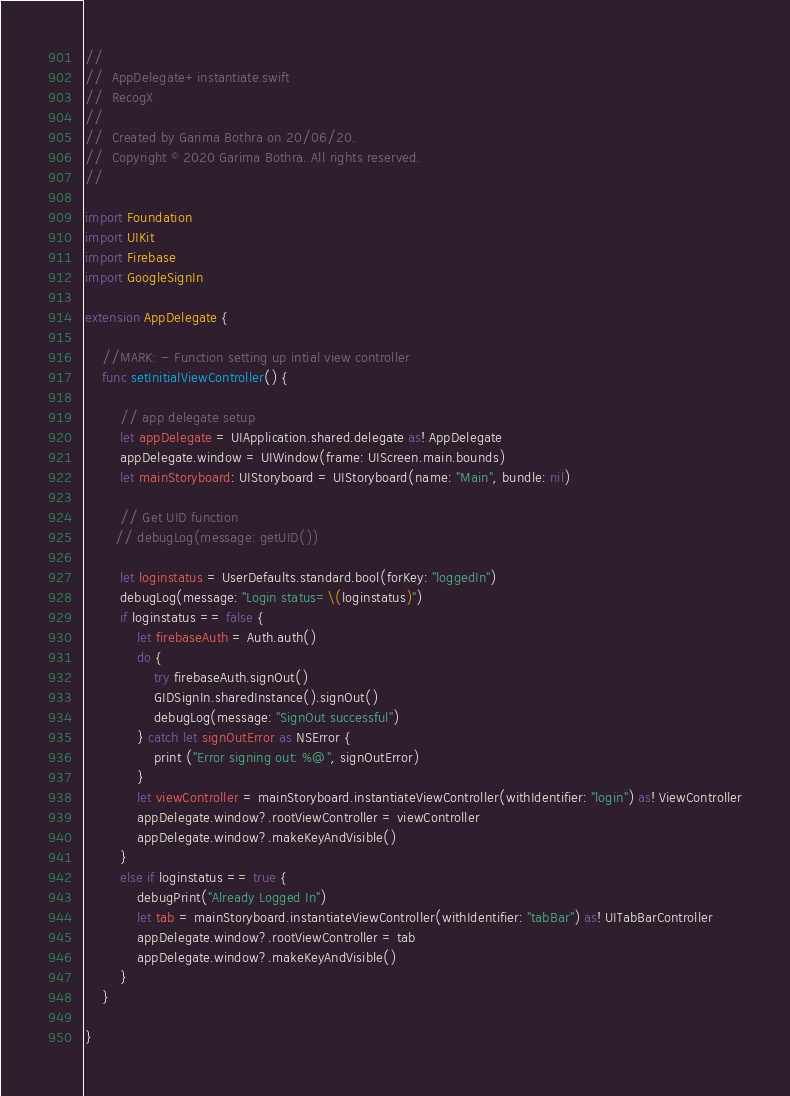Convert code to text. <code><loc_0><loc_0><loc_500><loc_500><_Swift_>//
//  AppDelegate+instantiate.swift
//  RecogX
//
//  Created by Garima Bothra on 20/06/20.
//  Copyright © 2020 Garima Bothra. All rights reserved.
//

import Foundation
import UIKit
import Firebase
import GoogleSignIn

extension AppDelegate {

    //MARK: - Function setting up intial view controller
    func setInitialViewController() {

        // app delegate setup
        let appDelegate = UIApplication.shared.delegate as! AppDelegate
        appDelegate.window = UIWindow(frame: UIScreen.main.bounds)
        let mainStoryboard: UIStoryboard = UIStoryboard(name: "Main", bundle: nil)

        // Get UID function
       // debugLog(message: getUID())

        let loginstatus = UserDefaults.standard.bool(forKey: "loggedIn")
        debugLog(message: "Login status=\(loginstatus)")
        if loginstatus == false {
            let firebaseAuth = Auth.auth()
            do {
                try firebaseAuth.signOut()
                GIDSignIn.sharedInstance().signOut()
                debugLog(message: "SignOut successful")
            } catch let signOutError as NSError {
                print ("Error signing out: %@", signOutError)
            }
            let viewController = mainStoryboard.instantiateViewController(withIdentifier: "login") as! ViewController
            appDelegate.window?.rootViewController = viewController
            appDelegate.window?.makeKeyAndVisible()
        }
        else if loginstatus == true {
            debugPrint("Already Logged In")
            let tab = mainStoryboard.instantiateViewController(withIdentifier: "tabBar") as! UITabBarController
            appDelegate.window?.rootViewController = tab
            appDelegate.window?.makeKeyAndVisible()
        }
    }

}
</code> 